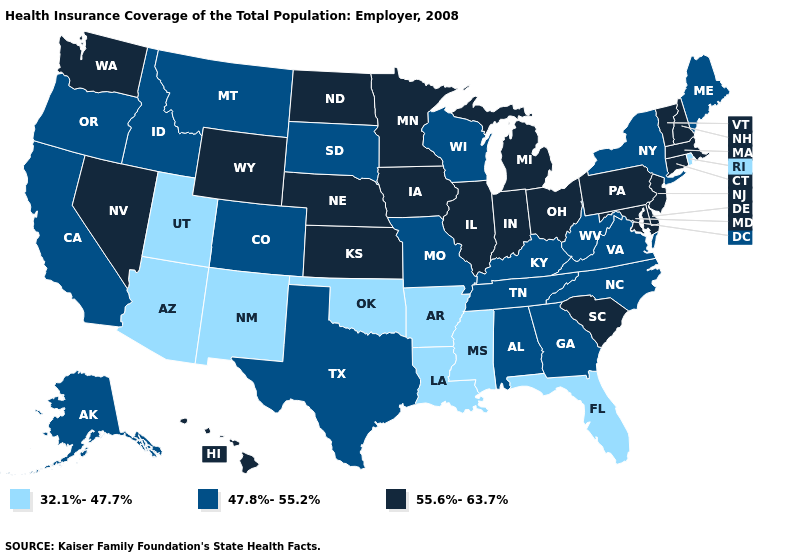How many symbols are there in the legend?
Short answer required. 3. Name the states that have a value in the range 32.1%-47.7%?
Quick response, please. Arizona, Arkansas, Florida, Louisiana, Mississippi, New Mexico, Oklahoma, Rhode Island, Utah. Among the states that border Iowa , which have the lowest value?
Answer briefly. Missouri, South Dakota, Wisconsin. Does Arizona have the highest value in the USA?
Be succinct. No. Name the states that have a value in the range 47.8%-55.2%?
Concise answer only. Alabama, Alaska, California, Colorado, Georgia, Idaho, Kentucky, Maine, Missouri, Montana, New York, North Carolina, Oregon, South Dakota, Tennessee, Texas, Virginia, West Virginia, Wisconsin. Name the states that have a value in the range 55.6%-63.7%?
Answer briefly. Connecticut, Delaware, Hawaii, Illinois, Indiana, Iowa, Kansas, Maryland, Massachusetts, Michigan, Minnesota, Nebraska, Nevada, New Hampshire, New Jersey, North Dakota, Ohio, Pennsylvania, South Carolina, Vermont, Washington, Wyoming. What is the value of Florida?
Keep it brief. 32.1%-47.7%. Among the states that border Indiana , which have the lowest value?
Concise answer only. Kentucky. What is the value of Michigan?
Give a very brief answer. 55.6%-63.7%. What is the highest value in the Northeast ?
Keep it brief. 55.6%-63.7%. Does Pennsylvania have the same value as Connecticut?
Write a very short answer. Yes. What is the lowest value in the USA?
Answer briefly. 32.1%-47.7%. Name the states that have a value in the range 55.6%-63.7%?
Concise answer only. Connecticut, Delaware, Hawaii, Illinois, Indiana, Iowa, Kansas, Maryland, Massachusetts, Michigan, Minnesota, Nebraska, Nevada, New Hampshire, New Jersey, North Dakota, Ohio, Pennsylvania, South Carolina, Vermont, Washington, Wyoming. What is the value of North Dakota?
Short answer required. 55.6%-63.7%. Name the states that have a value in the range 32.1%-47.7%?
Concise answer only. Arizona, Arkansas, Florida, Louisiana, Mississippi, New Mexico, Oklahoma, Rhode Island, Utah. 